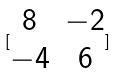<formula> <loc_0><loc_0><loc_500><loc_500>[ \begin{matrix} 8 & - 2 \\ - 4 & 6 \end{matrix} ]</formula> 